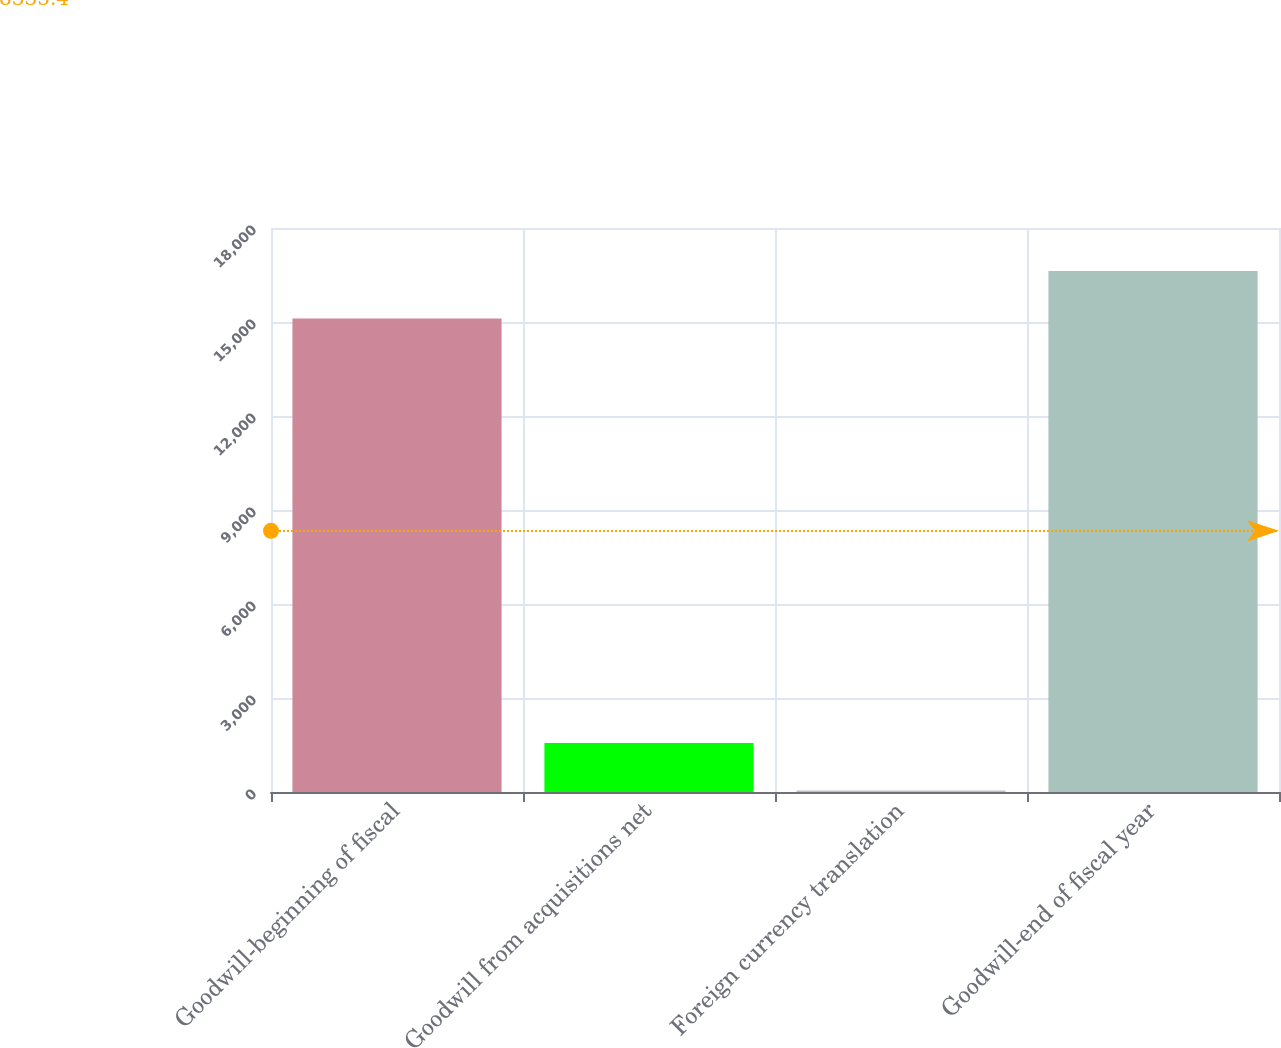<chart> <loc_0><loc_0><loc_500><loc_500><bar_chart><fcel>Goodwill-beginning of fiscal<fcel>Goodwill from acquisitions net<fcel>Foreign currency translation<fcel>Goodwill-end of fiscal year<nl><fcel>15110<fcel>1560.8<fcel>46<fcel>16624.8<nl></chart> 